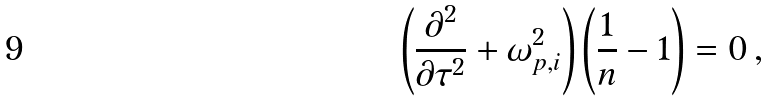<formula> <loc_0><loc_0><loc_500><loc_500>\left ( \frac { \partial ^ { 2 } } { \partial \tau ^ { 2 } } + \omega _ { p , i } ^ { 2 } \right ) \left ( \frac { 1 } { n } - 1 \right ) = 0 \, ,</formula> 